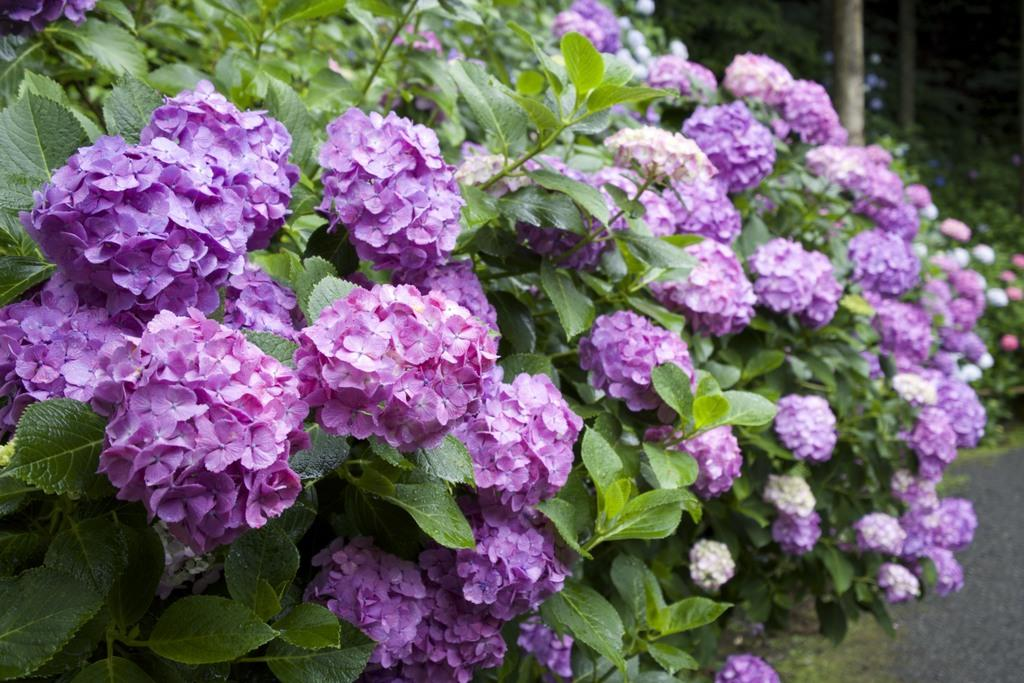What type of plant is depicted in the image? There is a bunch of flowers in the image. What parts of the plant can be seen in the image? There are leaves and a stem visible in the image. What else is present in the image besides the plant? There is a road in the image. Can you tell me how many friends are talking in the club in the image? There is no mention of friends or a club in the image; it features a bunch of flowers, leaves, a stem, and a road. 